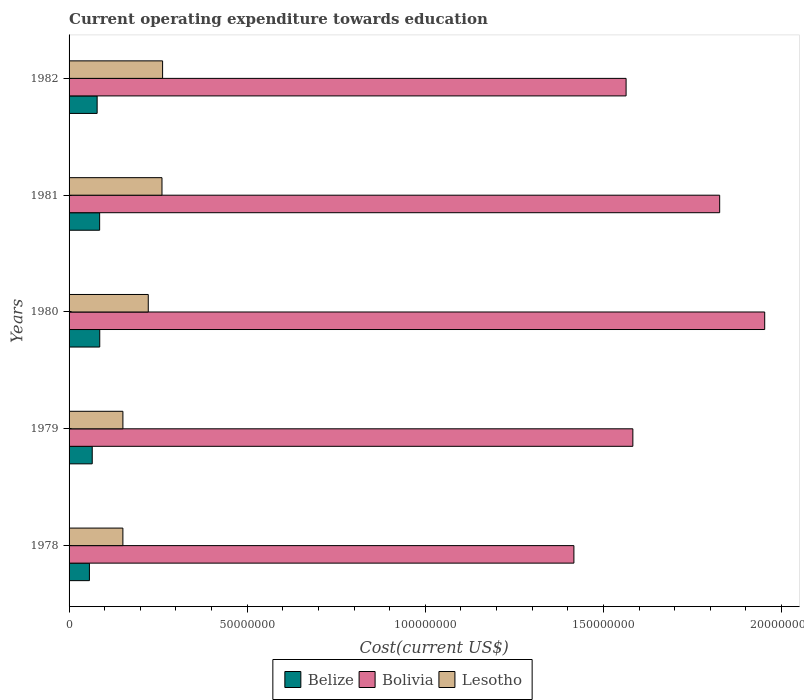How many different coloured bars are there?
Make the answer very short. 3. What is the expenditure towards education in Bolivia in 1978?
Ensure brevity in your answer.  1.42e+08. Across all years, what is the maximum expenditure towards education in Lesotho?
Your response must be concise. 2.63e+07. Across all years, what is the minimum expenditure towards education in Lesotho?
Provide a short and direct response. 1.51e+07. In which year was the expenditure towards education in Belize minimum?
Provide a short and direct response. 1978. What is the total expenditure towards education in Lesotho in the graph?
Your answer should be compact. 1.05e+08. What is the difference between the expenditure towards education in Lesotho in 1979 and that in 1982?
Your response must be concise. -1.11e+07. What is the difference between the expenditure towards education in Belize in 1981 and the expenditure towards education in Bolivia in 1982?
Provide a succinct answer. -1.48e+08. What is the average expenditure towards education in Belize per year?
Provide a short and direct response. 7.46e+06. In the year 1982, what is the difference between the expenditure towards education in Bolivia and expenditure towards education in Belize?
Make the answer very short. 1.48e+08. What is the ratio of the expenditure towards education in Lesotho in 1980 to that in 1981?
Make the answer very short. 0.85. What is the difference between the highest and the second highest expenditure towards education in Lesotho?
Your answer should be compact. 1.72e+05. What is the difference between the highest and the lowest expenditure towards education in Bolivia?
Offer a terse response. 5.36e+07. In how many years, is the expenditure towards education in Bolivia greater than the average expenditure towards education in Bolivia taken over all years?
Ensure brevity in your answer.  2. Is the sum of the expenditure towards education in Bolivia in 1978 and 1979 greater than the maximum expenditure towards education in Belize across all years?
Keep it short and to the point. Yes. What does the 2nd bar from the top in 1979 represents?
Offer a very short reply. Bolivia. What does the 3rd bar from the bottom in 1979 represents?
Keep it short and to the point. Lesotho. Is it the case that in every year, the sum of the expenditure towards education in Bolivia and expenditure towards education in Belize is greater than the expenditure towards education in Lesotho?
Keep it short and to the point. Yes. How many bars are there?
Offer a very short reply. 15. Are all the bars in the graph horizontal?
Provide a succinct answer. Yes. How many years are there in the graph?
Provide a short and direct response. 5. Are the values on the major ticks of X-axis written in scientific E-notation?
Provide a succinct answer. No. Does the graph contain any zero values?
Your answer should be compact. No. How many legend labels are there?
Offer a very short reply. 3. What is the title of the graph?
Offer a very short reply. Current operating expenditure towards education. Does "Virgin Islands" appear as one of the legend labels in the graph?
Provide a short and direct response. No. What is the label or title of the X-axis?
Your answer should be compact. Cost(current US$). What is the label or title of the Y-axis?
Keep it short and to the point. Years. What is the Cost(current US$) of Belize in 1978?
Give a very brief answer. 5.72e+06. What is the Cost(current US$) in Bolivia in 1978?
Keep it short and to the point. 1.42e+08. What is the Cost(current US$) of Lesotho in 1978?
Your response must be concise. 1.51e+07. What is the Cost(current US$) in Belize in 1979?
Offer a terse response. 6.50e+06. What is the Cost(current US$) of Bolivia in 1979?
Your answer should be very brief. 1.58e+08. What is the Cost(current US$) of Lesotho in 1979?
Offer a terse response. 1.51e+07. What is the Cost(current US$) in Belize in 1980?
Ensure brevity in your answer.  8.61e+06. What is the Cost(current US$) of Bolivia in 1980?
Ensure brevity in your answer.  1.95e+08. What is the Cost(current US$) of Lesotho in 1980?
Provide a succinct answer. 2.22e+07. What is the Cost(current US$) in Belize in 1981?
Offer a terse response. 8.58e+06. What is the Cost(current US$) of Bolivia in 1981?
Offer a terse response. 1.83e+08. What is the Cost(current US$) in Lesotho in 1981?
Provide a short and direct response. 2.61e+07. What is the Cost(current US$) in Belize in 1982?
Your answer should be very brief. 7.88e+06. What is the Cost(current US$) in Bolivia in 1982?
Your answer should be compact. 1.56e+08. What is the Cost(current US$) of Lesotho in 1982?
Give a very brief answer. 2.63e+07. Across all years, what is the maximum Cost(current US$) in Belize?
Give a very brief answer. 8.61e+06. Across all years, what is the maximum Cost(current US$) of Bolivia?
Ensure brevity in your answer.  1.95e+08. Across all years, what is the maximum Cost(current US$) of Lesotho?
Offer a very short reply. 2.63e+07. Across all years, what is the minimum Cost(current US$) in Belize?
Provide a short and direct response. 5.72e+06. Across all years, what is the minimum Cost(current US$) of Bolivia?
Provide a succinct answer. 1.42e+08. Across all years, what is the minimum Cost(current US$) of Lesotho?
Provide a short and direct response. 1.51e+07. What is the total Cost(current US$) in Belize in the graph?
Give a very brief answer. 3.73e+07. What is the total Cost(current US$) of Bolivia in the graph?
Ensure brevity in your answer.  8.34e+08. What is the total Cost(current US$) of Lesotho in the graph?
Your answer should be compact. 1.05e+08. What is the difference between the Cost(current US$) of Belize in 1978 and that in 1979?
Give a very brief answer. -7.89e+05. What is the difference between the Cost(current US$) of Bolivia in 1978 and that in 1979?
Give a very brief answer. -1.66e+07. What is the difference between the Cost(current US$) of Lesotho in 1978 and that in 1979?
Your answer should be very brief. -6378.56. What is the difference between the Cost(current US$) in Belize in 1978 and that in 1980?
Keep it short and to the point. -2.90e+06. What is the difference between the Cost(current US$) in Bolivia in 1978 and that in 1980?
Provide a short and direct response. -5.36e+07. What is the difference between the Cost(current US$) of Lesotho in 1978 and that in 1980?
Provide a succinct answer. -7.13e+06. What is the difference between the Cost(current US$) of Belize in 1978 and that in 1981?
Your answer should be compact. -2.87e+06. What is the difference between the Cost(current US$) of Bolivia in 1978 and that in 1981?
Ensure brevity in your answer.  -4.09e+07. What is the difference between the Cost(current US$) of Lesotho in 1978 and that in 1981?
Provide a succinct answer. -1.10e+07. What is the difference between the Cost(current US$) of Belize in 1978 and that in 1982?
Provide a succinct answer. -2.17e+06. What is the difference between the Cost(current US$) in Bolivia in 1978 and that in 1982?
Ensure brevity in your answer.  -1.47e+07. What is the difference between the Cost(current US$) of Lesotho in 1978 and that in 1982?
Your answer should be very brief. -1.11e+07. What is the difference between the Cost(current US$) of Belize in 1979 and that in 1980?
Offer a very short reply. -2.11e+06. What is the difference between the Cost(current US$) in Bolivia in 1979 and that in 1980?
Your answer should be compact. -3.70e+07. What is the difference between the Cost(current US$) of Lesotho in 1979 and that in 1980?
Your answer should be very brief. -7.12e+06. What is the difference between the Cost(current US$) in Belize in 1979 and that in 1981?
Keep it short and to the point. -2.08e+06. What is the difference between the Cost(current US$) in Bolivia in 1979 and that in 1981?
Your response must be concise. -2.44e+07. What is the difference between the Cost(current US$) in Lesotho in 1979 and that in 1981?
Your answer should be very brief. -1.10e+07. What is the difference between the Cost(current US$) of Belize in 1979 and that in 1982?
Provide a short and direct response. -1.38e+06. What is the difference between the Cost(current US$) of Bolivia in 1979 and that in 1982?
Your answer should be compact. 1.90e+06. What is the difference between the Cost(current US$) in Lesotho in 1979 and that in 1982?
Ensure brevity in your answer.  -1.11e+07. What is the difference between the Cost(current US$) in Belize in 1980 and that in 1981?
Offer a terse response. 2.95e+04. What is the difference between the Cost(current US$) in Bolivia in 1980 and that in 1981?
Offer a terse response. 1.26e+07. What is the difference between the Cost(current US$) in Lesotho in 1980 and that in 1981?
Keep it short and to the point. -3.85e+06. What is the difference between the Cost(current US$) in Belize in 1980 and that in 1982?
Offer a very short reply. 7.31e+05. What is the difference between the Cost(current US$) in Bolivia in 1980 and that in 1982?
Keep it short and to the point. 3.89e+07. What is the difference between the Cost(current US$) of Lesotho in 1980 and that in 1982?
Provide a succinct answer. -4.02e+06. What is the difference between the Cost(current US$) of Belize in 1981 and that in 1982?
Keep it short and to the point. 7.02e+05. What is the difference between the Cost(current US$) in Bolivia in 1981 and that in 1982?
Provide a short and direct response. 2.63e+07. What is the difference between the Cost(current US$) of Lesotho in 1981 and that in 1982?
Your answer should be very brief. -1.72e+05. What is the difference between the Cost(current US$) in Belize in 1978 and the Cost(current US$) in Bolivia in 1979?
Offer a very short reply. -1.53e+08. What is the difference between the Cost(current US$) of Belize in 1978 and the Cost(current US$) of Lesotho in 1979?
Ensure brevity in your answer.  -9.40e+06. What is the difference between the Cost(current US$) in Bolivia in 1978 and the Cost(current US$) in Lesotho in 1979?
Provide a succinct answer. 1.27e+08. What is the difference between the Cost(current US$) of Belize in 1978 and the Cost(current US$) of Bolivia in 1980?
Ensure brevity in your answer.  -1.90e+08. What is the difference between the Cost(current US$) of Belize in 1978 and the Cost(current US$) of Lesotho in 1980?
Keep it short and to the point. -1.65e+07. What is the difference between the Cost(current US$) in Bolivia in 1978 and the Cost(current US$) in Lesotho in 1980?
Keep it short and to the point. 1.19e+08. What is the difference between the Cost(current US$) of Belize in 1978 and the Cost(current US$) of Bolivia in 1981?
Give a very brief answer. -1.77e+08. What is the difference between the Cost(current US$) of Belize in 1978 and the Cost(current US$) of Lesotho in 1981?
Provide a short and direct response. -2.04e+07. What is the difference between the Cost(current US$) in Bolivia in 1978 and the Cost(current US$) in Lesotho in 1981?
Keep it short and to the point. 1.16e+08. What is the difference between the Cost(current US$) of Belize in 1978 and the Cost(current US$) of Bolivia in 1982?
Give a very brief answer. -1.51e+08. What is the difference between the Cost(current US$) of Belize in 1978 and the Cost(current US$) of Lesotho in 1982?
Your answer should be compact. -2.05e+07. What is the difference between the Cost(current US$) in Bolivia in 1978 and the Cost(current US$) in Lesotho in 1982?
Offer a terse response. 1.15e+08. What is the difference between the Cost(current US$) in Belize in 1979 and the Cost(current US$) in Bolivia in 1980?
Offer a very short reply. -1.89e+08. What is the difference between the Cost(current US$) of Belize in 1979 and the Cost(current US$) of Lesotho in 1980?
Ensure brevity in your answer.  -1.57e+07. What is the difference between the Cost(current US$) of Bolivia in 1979 and the Cost(current US$) of Lesotho in 1980?
Keep it short and to the point. 1.36e+08. What is the difference between the Cost(current US$) in Belize in 1979 and the Cost(current US$) in Bolivia in 1981?
Keep it short and to the point. -1.76e+08. What is the difference between the Cost(current US$) of Belize in 1979 and the Cost(current US$) of Lesotho in 1981?
Offer a terse response. -1.96e+07. What is the difference between the Cost(current US$) in Bolivia in 1979 and the Cost(current US$) in Lesotho in 1981?
Make the answer very short. 1.32e+08. What is the difference between the Cost(current US$) of Belize in 1979 and the Cost(current US$) of Bolivia in 1982?
Ensure brevity in your answer.  -1.50e+08. What is the difference between the Cost(current US$) in Belize in 1979 and the Cost(current US$) in Lesotho in 1982?
Keep it short and to the point. -1.98e+07. What is the difference between the Cost(current US$) of Bolivia in 1979 and the Cost(current US$) of Lesotho in 1982?
Your answer should be compact. 1.32e+08. What is the difference between the Cost(current US$) in Belize in 1980 and the Cost(current US$) in Bolivia in 1981?
Your response must be concise. -1.74e+08. What is the difference between the Cost(current US$) of Belize in 1980 and the Cost(current US$) of Lesotho in 1981?
Offer a terse response. -1.75e+07. What is the difference between the Cost(current US$) in Bolivia in 1980 and the Cost(current US$) in Lesotho in 1981?
Give a very brief answer. 1.69e+08. What is the difference between the Cost(current US$) of Belize in 1980 and the Cost(current US$) of Bolivia in 1982?
Offer a terse response. -1.48e+08. What is the difference between the Cost(current US$) in Belize in 1980 and the Cost(current US$) in Lesotho in 1982?
Ensure brevity in your answer.  -1.76e+07. What is the difference between the Cost(current US$) in Bolivia in 1980 and the Cost(current US$) in Lesotho in 1982?
Your answer should be very brief. 1.69e+08. What is the difference between the Cost(current US$) in Belize in 1981 and the Cost(current US$) in Bolivia in 1982?
Your answer should be very brief. -1.48e+08. What is the difference between the Cost(current US$) of Belize in 1981 and the Cost(current US$) of Lesotho in 1982?
Ensure brevity in your answer.  -1.77e+07. What is the difference between the Cost(current US$) in Bolivia in 1981 and the Cost(current US$) in Lesotho in 1982?
Give a very brief answer. 1.56e+08. What is the average Cost(current US$) of Belize per year?
Offer a very short reply. 7.46e+06. What is the average Cost(current US$) in Bolivia per year?
Your response must be concise. 1.67e+08. What is the average Cost(current US$) in Lesotho per year?
Provide a short and direct response. 2.10e+07. In the year 1978, what is the difference between the Cost(current US$) in Belize and Cost(current US$) in Bolivia?
Offer a very short reply. -1.36e+08. In the year 1978, what is the difference between the Cost(current US$) of Belize and Cost(current US$) of Lesotho?
Ensure brevity in your answer.  -9.39e+06. In the year 1978, what is the difference between the Cost(current US$) in Bolivia and Cost(current US$) in Lesotho?
Your answer should be very brief. 1.27e+08. In the year 1979, what is the difference between the Cost(current US$) of Belize and Cost(current US$) of Bolivia?
Your answer should be very brief. -1.52e+08. In the year 1979, what is the difference between the Cost(current US$) of Belize and Cost(current US$) of Lesotho?
Your answer should be compact. -8.61e+06. In the year 1979, what is the difference between the Cost(current US$) of Bolivia and Cost(current US$) of Lesotho?
Ensure brevity in your answer.  1.43e+08. In the year 1980, what is the difference between the Cost(current US$) of Belize and Cost(current US$) of Bolivia?
Offer a terse response. -1.87e+08. In the year 1980, what is the difference between the Cost(current US$) of Belize and Cost(current US$) of Lesotho?
Keep it short and to the point. -1.36e+07. In the year 1980, what is the difference between the Cost(current US$) of Bolivia and Cost(current US$) of Lesotho?
Provide a short and direct response. 1.73e+08. In the year 1981, what is the difference between the Cost(current US$) of Belize and Cost(current US$) of Bolivia?
Offer a very short reply. -1.74e+08. In the year 1981, what is the difference between the Cost(current US$) in Belize and Cost(current US$) in Lesotho?
Provide a succinct answer. -1.75e+07. In the year 1981, what is the difference between the Cost(current US$) in Bolivia and Cost(current US$) in Lesotho?
Provide a succinct answer. 1.57e+08. In the year 1982, what is the difference between the Cost(current US$) of Belize and Cost(current US$) of Bolivia?
Provide a short and direct response. -1.48e+08. In the year 1982, what is the difference between the Cost(current US$) of Belize and Cost(current US$) of Lesotho?
Your answer should be compact. -1.84e+07. In the year 1982, what is the difference between the Cost(current US$) in Bolivia and Cost(current US$) in Lesotho?
Offer a terse response. 1.30e+08. What is the ratio of the Cost(current US$) of Belize in 1978 to that in 1979?
Provide a short and direct response. 0.88. What is the ratio of the Cost(current US$) of Bolivia in 1978 to that in 1979?
Provide a succinct answer. 0.9. What is the ratio of the Cost(current US$) in Lesotho in 1978 to that in 1979?
Your answer should be compact. 1. What is the ratio of the Cost(current US$) of Belize in 1978 to that in 1980?
Your answer should be compact. 0.66. What is the ratio of the Cost(current US$) in Bolivia in 1978 to that in 1980?
Make the answer very short. 0.73. What is the ratio of the Cost(current US$) in Lesotho in 1978 to that in 1980?
Provide a short and direct response. 0.68. What is the ratio of the Cost(current US$) of Belize in 1978 to that in 1981?
Your answer should be very brief. 0.67. What is the ratio of the Cost(current US$) of Bolivia in 1978 to that in 1981?
Give a very brief answer. 0.78. What is the ratio of the Cost(current US$) in Lesotho in 1978 to that in 1981?
Offer a terse response. 0.58. What is the ratio of the Cost(current US$) in Belize in 1978 to that in 1982?
Give a very brief answer. 0.73. What is the ratio of the Cost(current US$) in Bolivia in 1978 to that in 1982?
Provide a short and direct response. 0.91. What is the ratio of the Cost(current US$) in Lesotho in 1978 to that in 1982?
Provide a succinct answer. 0.58. What is the ratio of the Cost(current US$) in Belize in 1979 to that in 1980?
Give a very brief answer. 0.76. What is the ratio of the Cost(current US$) of Bolivia in 1979 to that in 1980?
Keep it short and to the point. 0.81. What is the ratio of the Cost(current US$) of Lesotho in 1979 to that in 1980?
Provide a short and direct response. 0.68. What is the ratio of the Cost(current US$) of Belize in 1979 to that in 1981?
Your response must be concise. 0.76. What is the ratio of the Cost(current US$) in Bolivia in 1979 to that in 1981?
Your response must be concise. 0.87. What is the ratio of the Cost(current US$) of Lesotho in 1979 to that in 1981?
Your answer should be compact. 0.58. What is the ratio of the Cost(current US$) of Belize in 1979 to that in 1982?
Give a very brief answer. 0.83. What is the ratio of the Cost(current US$) in Bolivia in 1979 to that in 1982?
Keep it short and to the point. 1.01. What is the ratio of the Cost(current US$) in Lesotho in 1979 to that in 1982?
Your answer should be very brief. 0.58. What is the ratio of the Cost(current US$) in Bolivia in 1980 to that in 1981?
Make the answer very short. 1.07. What is the ratio of the Cost(current US$) in Lesotho in 1980 to that in 1981?
Keep it short and to the point. 0.85. What is the ratio of the Cost(current US$) of Belize in 1980 to that in 1982?
Offer a very short reply. 1.09. What is the ratio of the Cost(current US$) in Bolivia in 1980 to that in 1982?
Ensure brevity in your answer.  1.25. What is the ratio of the Cost(current US$) in Lesotho in 1980 to that in 1982?
Your response must be concise. 0.85. What is the ratio of the Cost(current US$) of Belize in 1981 to that in 1982?
Keep it short and to the point. 1.09. What is the ratio of the Cost(current US$) in Bolivia in 1981 to that in 1982?
Make the answer very short. 1.17. What is the ratio of the Cost(current US$) in Lesotho in 1981 to that in 1982?
Keep it short and to the point. 0.99. What is the difference between the highest and the second highest Cost(current US$) in Belize?
Offer a very short reply. 2.95e+04. What is the difference between the highest and the second highest Cost(current US$) of Bolivia?
Your answer should be compact. 1.26e+07. What is the difference between the highest and the second highest Cost(current US$) in Lesotho?
Provide a short and direct response. 1.72e+05. What is the difference between the highest and the lowest Cost(current US$) in Belize?
Offer a very short reply. 2.90e+06. What is the difference between the highest and the lowest Cost(current US$) in Bolivia?
Make the answer very short. 5.36e+07. What is the difference between the highest and the lowest Cost(current US$) in Lesotho?
Your answer should be compact. 1.11e+07. 